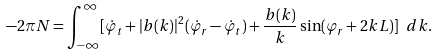Convert formula to latex. <formula><loc_0><loc_0><loc_500><loc_500>- 2 \pi N = \int _ { - \infty } ^ { \infty } [ \dot { \varphi } _ { t } + | b ( k ) | ^ { 2 } ( \dot { \varphi } _ { r } - \dot { \varphi } _ { t } ) + \frac { b ( k ) } { k } \sin ( \varphi _ { r } + 2 k L ) ] \ d k .</formula> 